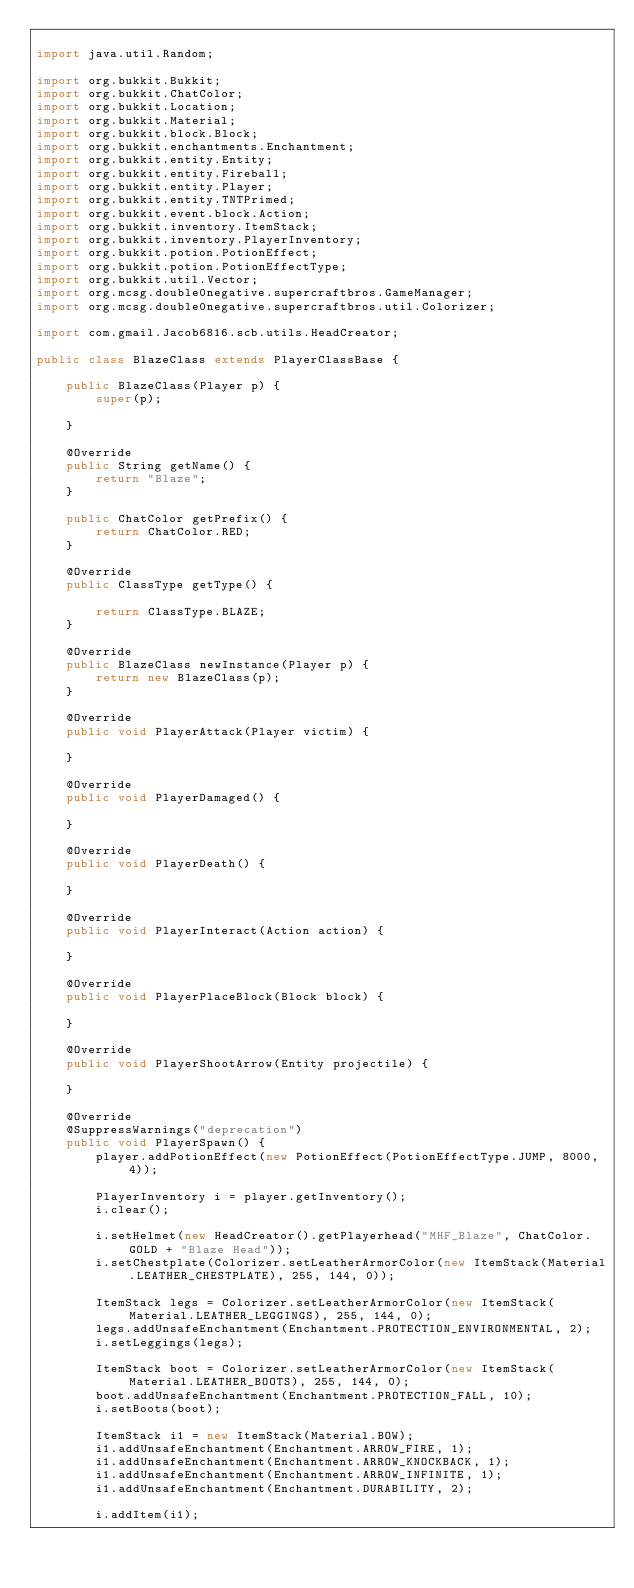Convert code to text. <code><loc_0><loc_0><loc_500><loc_500><_Java_>
import java.util.Random;

import org.bukkit.Bukkit;
import org.bukkit.ChatColor;
import org.bukkit.Location;
import org.bukkit.Material;
import org.bukkit.block.Block;
import org.bukkit.enchantments.Enchantment;
import org.bukkit.entity.Entity;
import org.bukkit.entity.Fireball;
import org.bukkit.entity.Player;
import org.bukkit.entity.TNTPrimed;
import org.bukkit.event.block.Action;
import org.bukkit.inventory.ItemStack;
import org.bukkit.inventory.PlayerInventory;
import org.bukkit.potion.PotionEffect;
import org.bukkit.potion.PotionEffectType;
import org.bukkit.util.Vector;
import org.mcsg.double0negative.supercraftbros.GameManager;
import org.mcsg.double0negative.supercraftbros.util.Colorizer;

import com.gmail.Jacob6816.scb.utils.HeadCreator;

public class BlazeClass extends PlayerClassBase {
    
    public BlazeClass(Player p) {
        super(p);
        
    }
    
    @Override
	public String getName() {
        return "Blaze";
    }
    
    public ChatColor getPrefix() {
        return ChatColor.RED;
    }
    
    @Override
	public ClassType getType() {
        
        return ClassType.BLAZE;
    }
    
    @Override
	public BlazeClass newInstance(Player p) {
        return new BlazeClass(p);
    }
    
    @Override
	public void PlayerAttack(Player victim) {
        
    }
    
    @Override
	public void PlayerDamaged() {
        
    }
    
    @Override
	public void PlayerDeath() {
        
    }
    
    @Override
	public void PlayerInteract(Action action) {
        
    }
    
    @Override
	public void PlayerPlaceBlock(Block block) {
        
    }
    
    @Override
	public void PlayerShootArrow(Entity projectile) {
        
    }
    
    @Override
	@SuppressWarnings("deprecation")
    public void PlayerSpawn() {
        player.addPotionEffect(new PotionEffect(PotionEffectType.JUMP, 8000, 4));
        
        PlayerInventory i = player.getInventory();
        i.clear();
        
        i.setHelmet(new HeadCreator().getPlayerhead("MHF_Blaze", ChatColor.GOLD + "Blaze Head"));
        i.setChestplate(Colorizer.setLeatherArmorColor(new ItemStack(Material.LEATHER_CHESTPLATE), 255, 144, 0));
        
        ItemStack legs = Colorizer.setLeatherArmorColor(new ItemStack(Material.LEATHER_LEGGINGS), 255, 144, 0);
        legs.addUnsafeEnchantment(Enchantment.PROTECTION_ENVIRONMENTAL, 2);
        i.setLeggings(legs);
        
        ItemStack boot = Colorizer.setLeatherArmorColor(new ItemStack(Material.LEATHER_BOOTS), 255, 144, 0);
        boot.addUnsafeEnchantment(Enchantment.PROTECTION_FALL, 10);
        i.setBoots(boot);
        
        ItemStack i1 = new ItemStack(Material.BOW);
        i1.addUnsafeEnchantment(Enchantment.ARROW_FIRE, 1);
        i1.addUnsafeEnchantment(Enchantment.ARROW_KNOCKBACK, 1);
        i1.addUnsafeEnchantment(Enchantment.ARROW_INFINITE, 1);
        i1.addUnsafeEnchantment(Enchantment.DURABILITY, 2);
        
        i.addItem(i1);
        </code> 